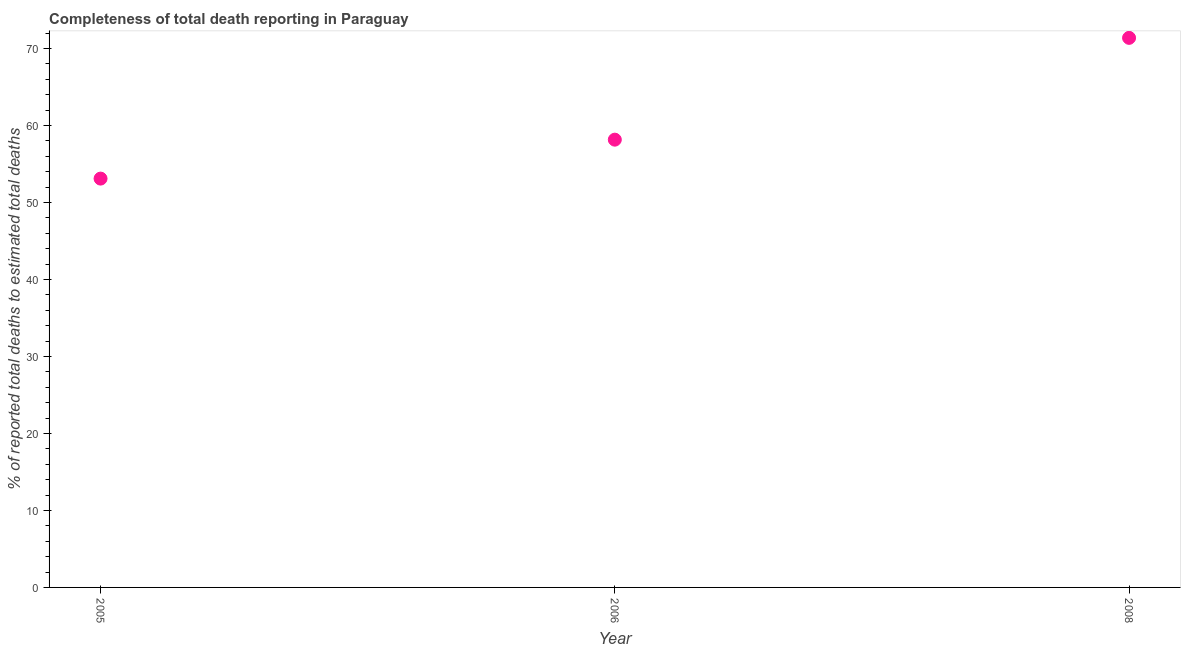What is the completeness of total death reports in 2005?
Make the answer very short. 53.1. Across all years, what is the maximum completeness of total death reports?
Offer a terse response. 71.38. Across all years, what is the minimum completeness of total death reports?
Keep it short and to the point. 53.1. What is the sum of the completeness of total death reports?
Ensure brevity in your answer.  182.63. What is the difference between the completeness of total death reports in 2006 and 2008?
Your answer should be compact. -13.22. What is the average completeness of total death reports per year?
Give a very brief answer. 60.88. What is the median completeness of total death reports?
Provide a short and direct response. 58.16. In how many years, is the completeness of total death reports greater than 52 %?
Provide a short and direct response. 3. What is the ratio of the completeness of total death reports in 2005 to that in 2006?
Provide a short and direct response. 0.91. Is the completeness of total death reports in 2005 less than that in 2008?
Give a very brief answer. Yes. Is the difference between the completeness of total death reports in 2005 and 2008 greater than the difference between any two years?
Ensure brevity in your answer.  Yes. What is the difference between the highest and the second highest completeness of total death reports?
Your answer should be compact. 13.22. What is the difference between the highest and the lowest completeness of total death reports?
Ensure brevity in your answer.  18.28. In how many years, is the completeness of total death reports greater than the average completeness of total death reports taken over all years?
Ensure brevity in your answer.  1. What is the difference between two consecutive major ticks on the Y-axis?
Offer a very short reply. 10. Are the values on the major ticks of Y-axis written in scientific E-notation?
Keep it short and to the point. No. Does the graph contain grids?
Your response must be concise. No. What is the title of the graph?
Make the answer very short. Completeness of total death reporting in Paraguay. What is the label or title of the X-axis?
Your answer should be very brief. Year. What is the label or title of the Y-axis?
Give a very brief answer. % of reported total deaths to estimated total deaths. What is the % of reported total deaths to estimated total deaths in 2005?
Ensure brevity in your answer.  53.1. What is the % of reported total deaths to estimated total deaths in 2006?
Ensure brevity in your answer.  58.16. What is the % of reported total deaths to estimated total deaths in 2008?
Ensure brevity in your answer.  71.38. What is the difference between the % of reported total deaths to estimated total deaths in 2005 and 2006?
Your response must be concise. -5.06. What is the difference between the % of reported total deaths to estimated total deaths in 2005 and 2008?
Make the answer very short. -18.28. What is the difference between the % of reported total deaths to estimated total deaths in 2006 and 2008?
Provide a short and direct response. -13.22. What is the ratio of the % of reported total deaths to estimated total deaths in 2005 to that in 2006?
Your answer should be very brief. 0.91. What is the ratio of the % of reported total deaths to estimated total deaths in 2005 to that in 2008?
Your answer should be compact. 0.74. What is the ratio of the % of reported total deaths to estimated total deaths in 2006 to that in 2008?
Give a very brief answer. 0.81. 